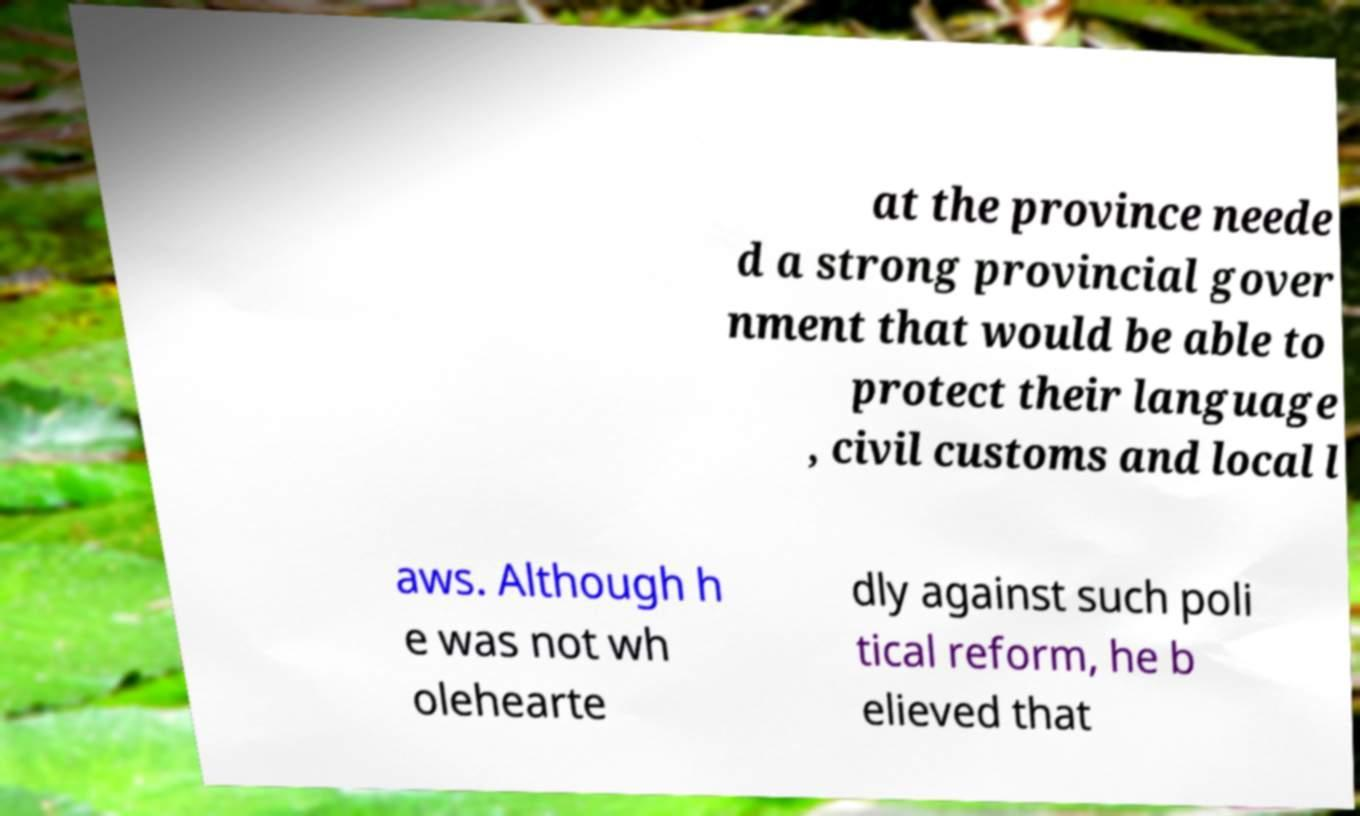Can you accurately transcribe the text from the provided image for me? at the province neede d a strong provincial gover nment that would be able to protect their language , civil customs and local l aws. Although h e was not wh olehearte dly against such poli tical reform, he b elieved that 